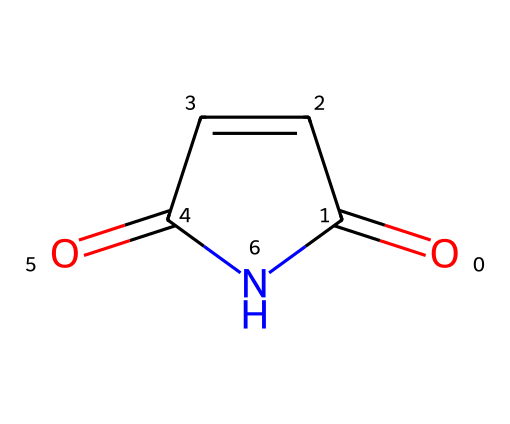What is the name of this chemical? The given SMILES representation (O=C1C=CC(=O)N1) corresponds to the structure of maleimide. This can be identified by recognizing the functional groups and the cyclic nature of the molecule.
Answer: maleimide How many carbon atoms are in maleimide? By analyzing the SMILES structure, we can count the number of carbon atoms present. The SMILES shows a total of four carbon atoms (C) in the cyclic structure.
Answer: 4 What type of functional groups are present in maleimide? The analysis of the SMILES depicts both carbonyl (C=O) and imide (N) functional groups, which are recognizable from the arrangement of atoms and bonds.
Answer: carbonyl and imide What is the degree of unsaturation in maleimide? The degree of unsaturation can be calculated from the formula: (1 + C - H/2 + N/2) based on the elements present. In this case, it shows a degree of unsaturation of 3, indicating the presence of rings and/or multiple bonds.
Answer: 3 Explain why maleimide can be used in polymer chemistry. Maleimide has a reactive double bond and an imide functional group that can undergo polymerization with other monomers, allowing it to participate in a variety of chemical reactions, particularly in creating thermosetting polymers.
Answer: reactive monomer Is maleimide an aromatic compound? No, maleimide contains a double bond and a cyclic structure but does not have the delocalized pi electrons characteristic of aromatic compounds.
Answer: no 